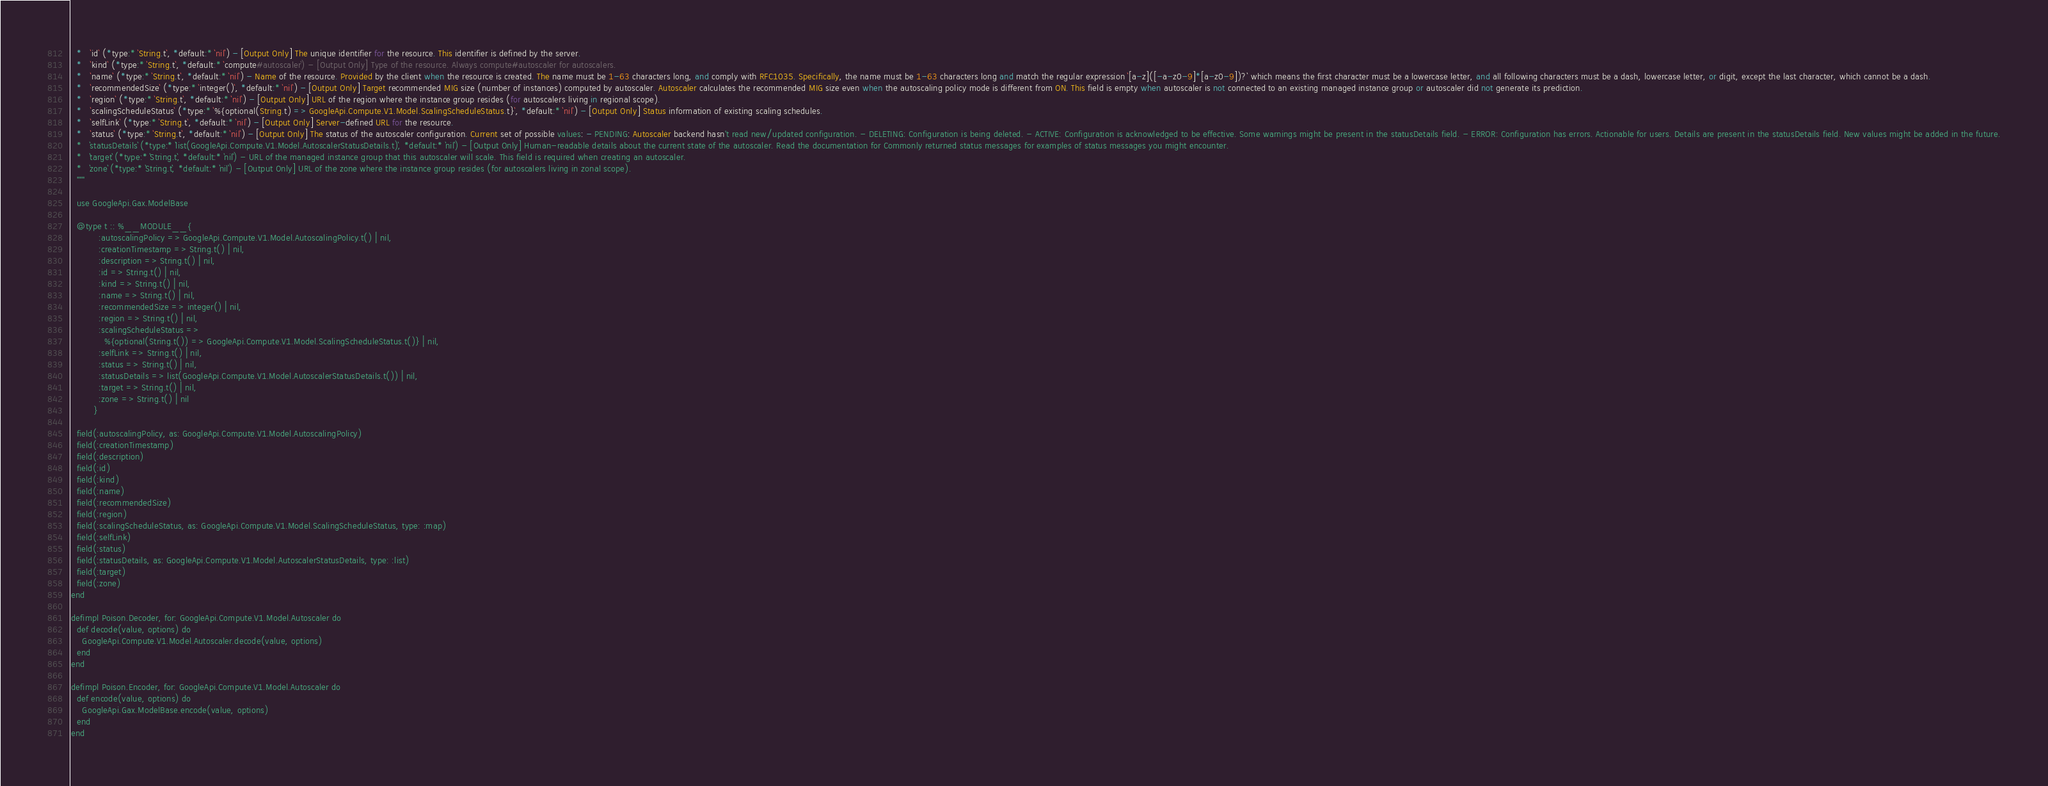<code> <loc_0><loc_0><loc_500><loc_500><_Elixir_>  *   `id` (*type:* `String.t`, *default:* `nil`) - [Output Only] The unique identifier for the resource. This identifier is defined by the server.
  *   `kind` (*type:* `String.t`, *default:* `compute#autoscaler`) - [Output Only] Type of the resource. Always compute#autoscaler for autoscalers.
  *   `name` (*type:* `String.t`, *default:* `nil`) - Name of the resource. Provided by the client when the resource is created. The name must be 1-63 characters long, and comply with RFC1035. Specifically, the name must be 1-63 characters long and match the regular expression `[a-z]([-a-z0-9]*[a-z0-9])?` which means the first character must be a lowercase letter, and all following characters must be a dash, lowercase letter, or digit, except the last character, which cannot be a dash.
  *   `recommendedSize` (*type:* `integer()`, *default:* `nil`) - [Output Only] Target recommended MIG size (number of instances) computed by autoscaler. Autoscaler calculates the recommended MIG size even when the autoscaling policy mode is different from ON. This field is empty when autoscaler is not connected to an existing managed instance group or autoscaler did not generate its prediction.
  *   `region` (*type:* `String.t`, *default:* `nil`) - [Output Only] URL of the region where the instance group resides (for autoscalers living in regional scope).
  *   `scalingScheduleStatus` (*type:* `%{optional(String.t) => GoogleApi.Compute.V1.Model.ScalingScheduleStatus.t}`, *default:* `nil`) - [Output Only] Status information of existing scaling schedules.
  *   `selfLink` (*type:* `String.t`, *default:* `nil`) - [Output Only] Server-defined URL for the resource.
  *   `status` (*type:* `String.t`, *default:* `nil`) - [Output Only] The status of the autoscaler configuration. Current set of possible values: - PENDING: Autoscaler backend hasn't read new/updated configuration. - DELETING: Configuration is being deleted. - ACTIVE: Configuration is acknowledged to be effective. Some warnings might be present in the statusDetails field. - ERROR: Configuration has errors. Actionable for users. Details are present in the statusDetails field. New values might be added in the future.
  *   `statusDetails` (*type:* `list(GoogleApi.Compute.V1.Model.AutoscalerStatusDetails.t)`, *default:* `nil`) - [Output Only] Human-readable details about the current state of the autoscaler. Read the documentation for Commonly returned status messages for examples of status messages you might encounter.
  *   `target` (*type:* `String.t`, *default:* `nil`) - URL of the managed instance group that this autoscaler will scale. This field is required when creating an autoscaler.
  *   `zone` (*type:* `String.t`, *default:* `nil`) - [Output Only] URL of the zone where the instance group resides (for autoscalers living in zonal scope).
  """

  use GoogleApi.Gax.ModelBase

  @type t :: %__MODULE__{
          :autoscalingPolicy => GoogleApi.Compute.V1.Model.AutoscalingPolicy.t() | nil,
          :creationTimestamp => String.t() | nil,
          :description => String.t() | nil,
          :id => String.t() | nil,
          :kind => String.t() | nil,
          :name => String.t() | nil,
          :recommendedSize => integer() | nil,
          :region => String.t() | nil,
          :scalingScheduleStatus =>
            %{optional(String.t()) => GoogleApi.Compute.V1.Model.ScalingScheduleStatus.t()} | nil,
          :selfLink => String.t() | nil,
          :status => String.t() | nil,
          :statusDetails => list(GoogleApi.Compute.V1.Model.AutoscalerStatusDetails.t()) | nil,
          :target => String.t() | nil,
          :zone => String.t() | nil
        }

  field(:autoscalingPolicy, as: GoogleApi.Compute.V1.Model.AutoscalingPolicy)
  field(:creationTimestamp)
  field(:description)
  field(:id)
  field(:kind)
  field(:name)
  field(:recommendedSize)
  field(:region)
  field(:scalingScheduleStatus, as: GoogleApi.Compute.V1.Model.ScalingScheduleStatus, type: :map)
  field(:selfLink)
  field(:status)
  field(:statusDetails, as: GoogleApi.Compute.V1.Model.AutoscalerStatusDetails, type: :list)
  field(:target)
  field(:zone)
end

defimpl Poison.Decoder, for: GoogleApi.Compute.V1.Model.Autoscaler do
  def decode(value, options) do
    GoogleApi.Compute.V1.Model.Autoscaler.decode(value, options)
  end
end

defimpl Poison.Encoder, for: GoogleApi.Compute.V1.Model.Autoscaler do
  def encode(value, options) do
    GoogleApi.Gax.ModelBase.encode(value, options)
  end
end
</code> 